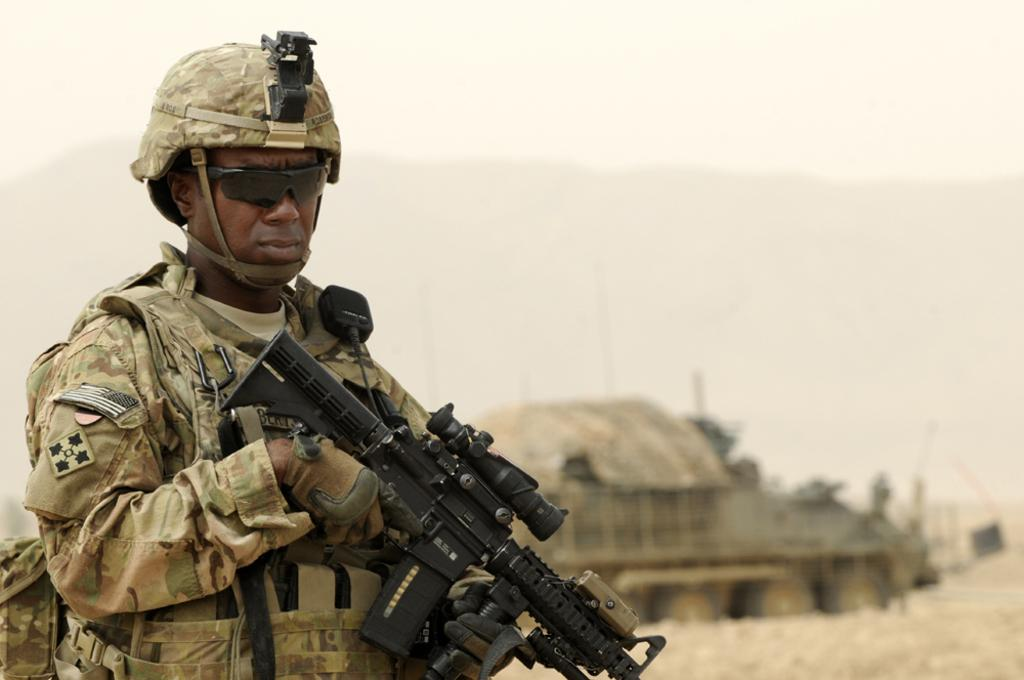Who is present in the image? There is a man in the image. What is the man wearing on his face? The man is wearing goggles. What is the man holding in the image? The man is holding a sniper rifle. What can be seen in the background of the image? There is a house and a hill in the background of the image. What type of farm animals can be seen in the image? There are no farm animals present in the image. 